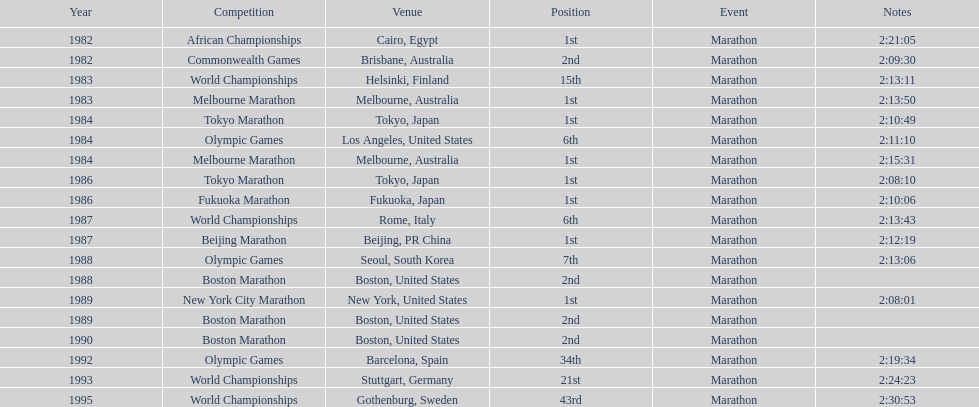In this chart, which competition is mentioned the most? World Championships. 